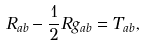Convert formula to latex. <formula><loc_0><loc_0><loc_500><loc_500>R _ { a b } - \frac { 1 } { 2 } R g _ { a b } = T _ { a b } ,</formula> 